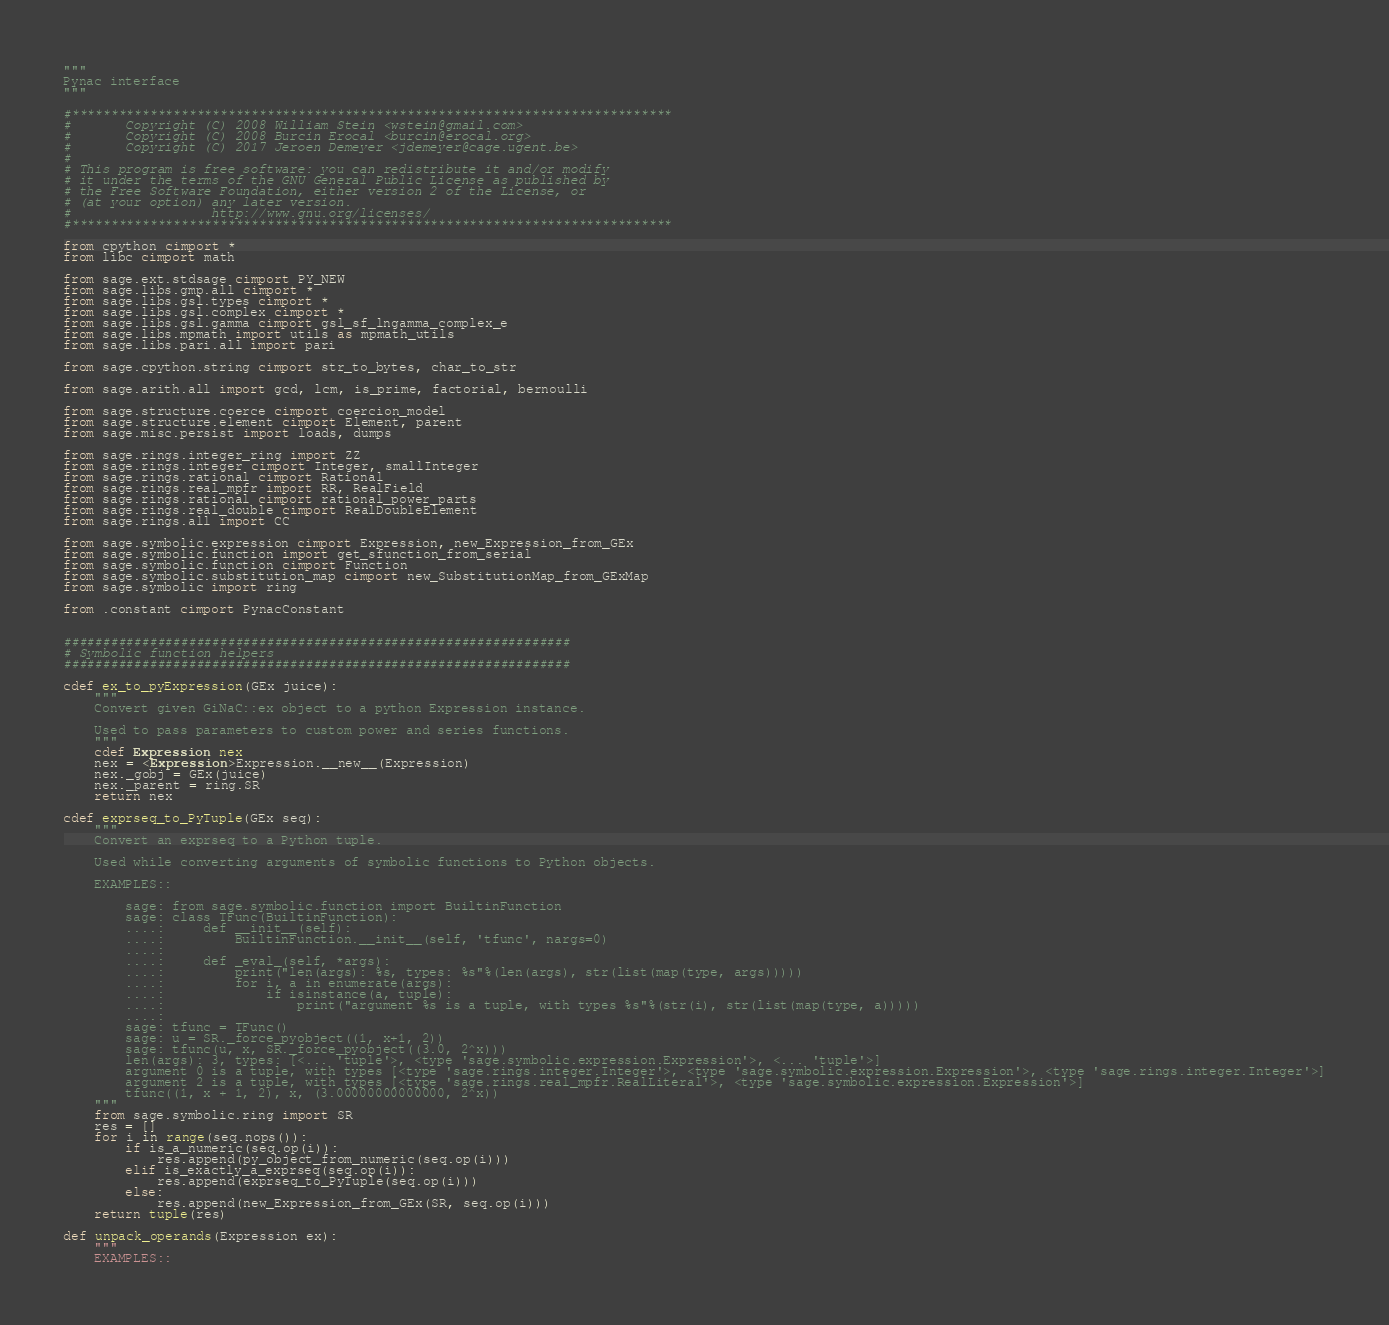<code> <loc_0><loc_0><loc_500><loc_500><_Cython_>"""
Pynac interface
"""

#*****************************************************************************
#       Copyright (C) 2008 William Stein <wstein@gmail.com>
#       Copyright (C) 2008 Burcin Erocal <burcin@erocal.org>
#       Copyright (C) 2017 Jeroen Demeyer <jdemeyer@cage.ugent.be>
#
# This program is free software: you can redistribute it and/or modify
# it under the terms of the GNU General Public License as published by
# the Free Software Foundation, either version 2 of the License, or
# (at your option) any later version.
#                  http://www.gnu.org/licenses/
#*****************************************************************************

from cpython cimport *
from libc cimport math

from sage.ext.stdsage cimport PY_NEW
from sage.libs.gmp.all cimport *
from sage.libs.gsl.types cimport *
from sage.libs.gsl.complex cimport *
from sage.libs.gsl.gamma cimport gsl_sf_lngamma_complex_e
from sage.libs.mpmath import utils as mpmath_utils
from sage.libs.pari.all import pari

from sage.cpython.string cimport str_to_bytes, char_to_str

from sage.arith.all import gcd, lcm, is_prime, factorial, bernoulli

from sage.structure.coerce cimport coercion_model
from sage.structure.element cimport Element, parent
from sage.misc.persist import loads, dumps

from sage.rings.integer_ring import ZZ
from sage.rings.integer cimport Integer, smallInteger
from sage.rings.rational cimport Rational
from sage.rings.real_mpfr import RR, RealField
from sage.rings.rational cimport rational_power_parts
from sage.rings.real_double cimport RealDoubleElement
from sage.rings.all import CC

from sage.symbolic.expression cimport Expression, new_Expression_from_GEx
from sage.symbolic.function import get_sfunction_from_serial
from sage.symbolic.function cimport Function
from sage.symbolic.substitution_map cimport new_SubstitutionMap_from_GExMap
from sage.symbolic import ring

from .constant cimport PynacConstant


#################################################################
# Symbolic function helpers
#################################################################

cdef ex_to_pyExpression(GEx juice):
    """
    Convert given GiNaC::ex object to a python Expression instance.

    Used to pass parameters to custom power and series functions.
    """
    cdef Expression nex
    nex = <Expression>Expression.__new__(Expression)
    nex._gobj = GEx(juice)
    nex._parent = ring.SR
    return nex

cdef exprseq_to_PyTuple(GEx seq):
    """
    Convert an exprseq to a Python tuple.

    Used while converting arguments of symbolic functions to Python objects.

    EXAMPLES::

        sage: from sage.symbolic.function import BuiltinFunction
        sage: class TFunc(BuiltinFunction):
        ....:     def __init__(self):
        ....:         BuiltinFunction.__init__(self, 'tfunc', nargs=0)
        ....:
        ....:     def _eval_(self, *args):
        ....:         print("len(args): %s, types: %s"%(len(args), str(list(map(type, args)))))
        ....:         for i, a in enumerate(args):
        ....:             if isinstance(a, tuple):
        ....:                 print("argument %s is a tuple, with types %s"%(str(i), str(list(map(type, a)))))
        ....:
        sage: tfunc = TFunc()
        sage: u = SR._force_pyobject((1, x+1, 2))
        sage: tfunc(u, x, SR._force_pyobject((3.0, 2^x)))
        len(args): 3, types: [<... 'tuple'>, <type 'sage.symbolic.expression.Expression'>, <... 'tuple'>]
        argument 0 is a tuple, with types [<type 'sage.rings.integer.Integer'>, <type 'sage.symbolic.expression.Expression'>, <type 'sage.rings.integer.Integer'>]
        argument 2 is a tuple, with types [<type 'sage.rings.real_mpfr.RealLiteral'>, <type 'sage.symbolic.expression.Expression'>]
        tfunc((1, x + 1, 2), x, (3.00000000000000, 2^x))
    """
    from sage.symbolic.ring import SR
    res = []
    for i in range(seq.nops()):
        if is_a_numeric(seq.op(i)):
            res.append(py_object_from_numeric(seq.op(i)))
        elif is_exactly_a_exprseq(seq.op(i)):
            res.append(exprseq_to_PyTuple(seq.op(i)))
        else:
            res.append(new_Expression_from_GEx(SR, seq.op(i)))
    return tuple(res)

def unpack_operands(Expression ex):
    """
    EXAMPLES::
</code> 